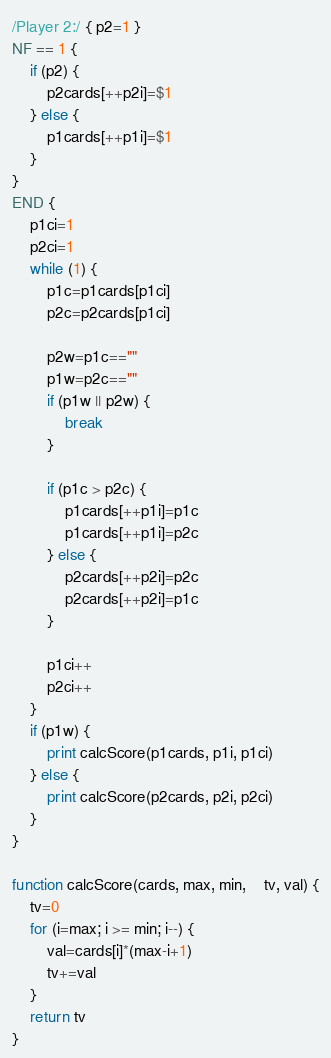Convert code to text. <code><loc_0><loc_0><loc_500><loc_500><_Awk_>/Player 2:/ { p2=1 }
NF == 1 {
	if (p2) {
		p2cards[++p2i]=$1
	} else {
		p1cards[++p1i]=$1
	}
}
END {
	p1ci=1
	p2ci=1
	while (1) {
		p1c=p1cards[p1ci]
		p2c=p2cards[p1ci]

		p2w=p1c==""
		p1w=p2c==""
		if (p1w || p2w) {
			break
		}

		if (p1c > p2c) {
			p1cards[++p1i]=p1c
			p1cards[++p1i]=p2c
		} else {
			p2cards[++p2i]=p2c
			p2cards[++p2i]=p1c
		}

		p1ci++
		p2ci++
	}
	if (p1w) {
		print calcScore(p1cards, p1i, p1ci)
	} else {
		print calcScore(p2cards, p2i, p2ci)
	}
}

function calcScore(cards, max, min,	tv, val) {
	tv=0
	for (i=max; i >= min; i--) {
		val=cards[i]*(max-i+1)
		tv+=val
	}
	return tv
}</code> 